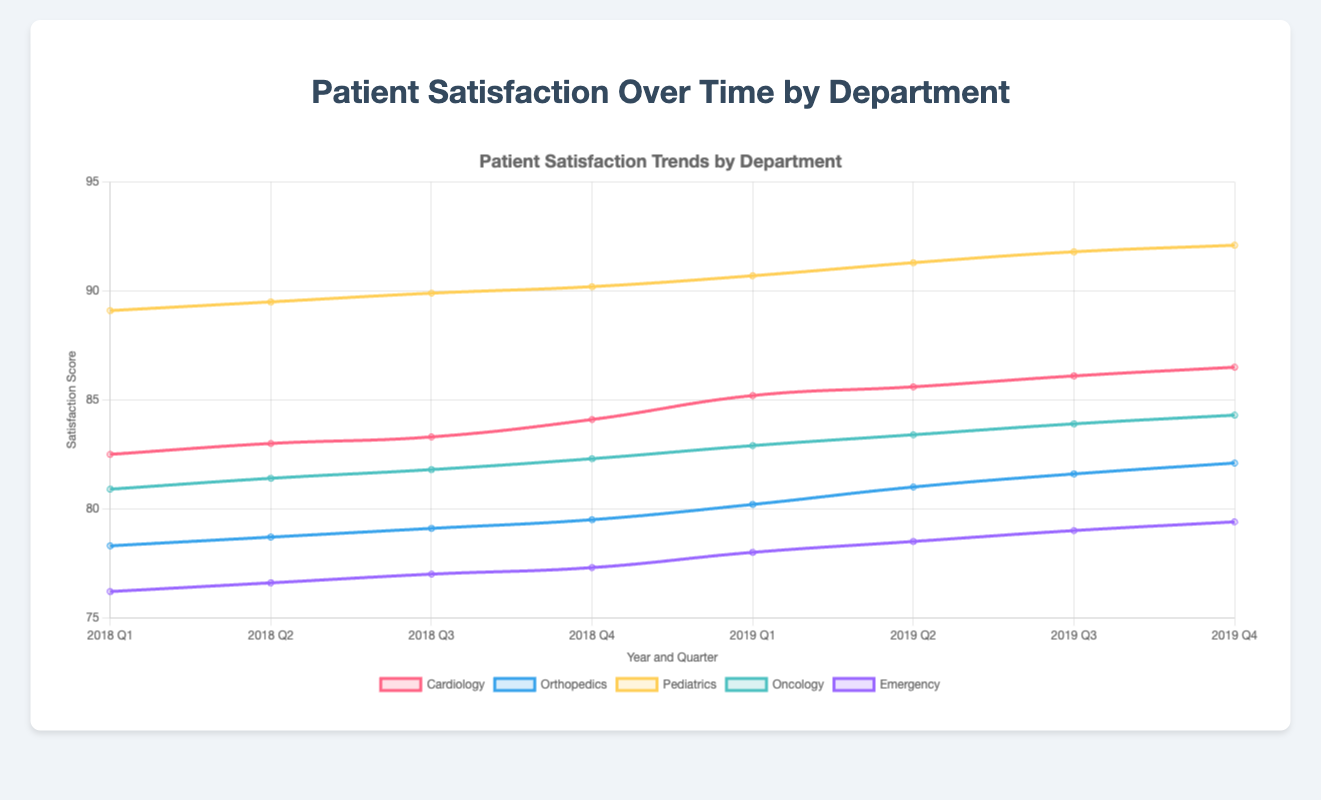What's the average satisfaction score for Cardiology in 2018? To find the average satisfaction score for Cardiology in 2018, sum the satisfaction scores for Q1, Q2, Q3, and Q4, and then divide by 4. (82.5 + 83.0 + 83.3 + 84.1) / 4 = 332.9 / 4 = 83.225
Answer: 83.225 Which department had the highest satisfaction score in Q4 of 2019? Compare the satisfaction scores for Q4 of 2019 for all departments: Cardiology (86.5), Orthopedics (82.1), Pediatrics (92.1), Oncology (84.3), and Emergency (79.4). Pediatrics has the highest score with 92.1.
Answer: Pediatrics Between 2018 and 2019, which department showed the greatest overall improvement in satisfaction score? Calculate the difference in satisfaction score from Q1 2018 to Q4 2019 for each department: 
Cardiology: 86.5 - 82.5 = 4.0 
Orthopedics: 82.1 - 78.3 = 3.8 
Pediatrics: 92.1 - 89.1 = 3.0 
Oncology: 84.3 - 80.9 = 3.4 
Emergency: 79.4 - 76.2 = 3.2 
Cardiology showed the greatest overall improvement of 4.0 points.
Answer: Cardiology Comparing Q1 2019 to Q1 2018, which department had the smallest increase in satisfaction score? Calculate the increase in satisfaction score from Q1 2018 to Q1 2019 for each department: 
Cardiology: 85.2 - 82.5 = 2.7 
Orthopedics: 80.2 - 78.3 = 1.9 
Pediatrics: 90.7 - 89.1 = 1.6 
Oncology: 82.9 - 80.9 = 2.0 
Emergency: 78.0 - 76.2 = 1.8 
Pediatrics had the smallest increase with 1.6 points.
Answer: Pediatrics During which quarter and year did the Emergency department have its highest satisfaction score? Look through the data for Emergency department's satisfaction scores: 
2018 Q1 - 76.2 
2018 Q2 - 76.6 
2018 Q3 - 77.0 
2018 Q4 - 77.3 
2019 Q1 - 78.0 
2019 Q2 - 78.5 
2019 Q3 - 79.0 
2019 Q4 - 79.4 
The highest score is in Q4 of 2019 with 79.4.
Answer: Q4 2019 What is the difference in the highest satisfaction score between Pediatrics and Orthopedics in Q4 2018? Identify the satisfaction scores for Pediatrics (90.2) and Orthopedics (79.5) in Q4 2018. Calculate the difference: 90.2 - 79.5 = 10.7.
Answer: 10.7 What is the trend in Oncology department satisfaction scores between 2018 and 2019? Summarize the quarterly satisfaction scores for Oncology: 
2018: Q1 - 80.9, Q2 - 81.4, Q3 - 81.8, Q4 - 82.3 
2019: Q1 - 82.9, Q2 - 83.4, Q3 - 83.9, Q4 - 84.3 
There is a consistent increase in satisfaction every quarter.
Answer: Consistent increase 